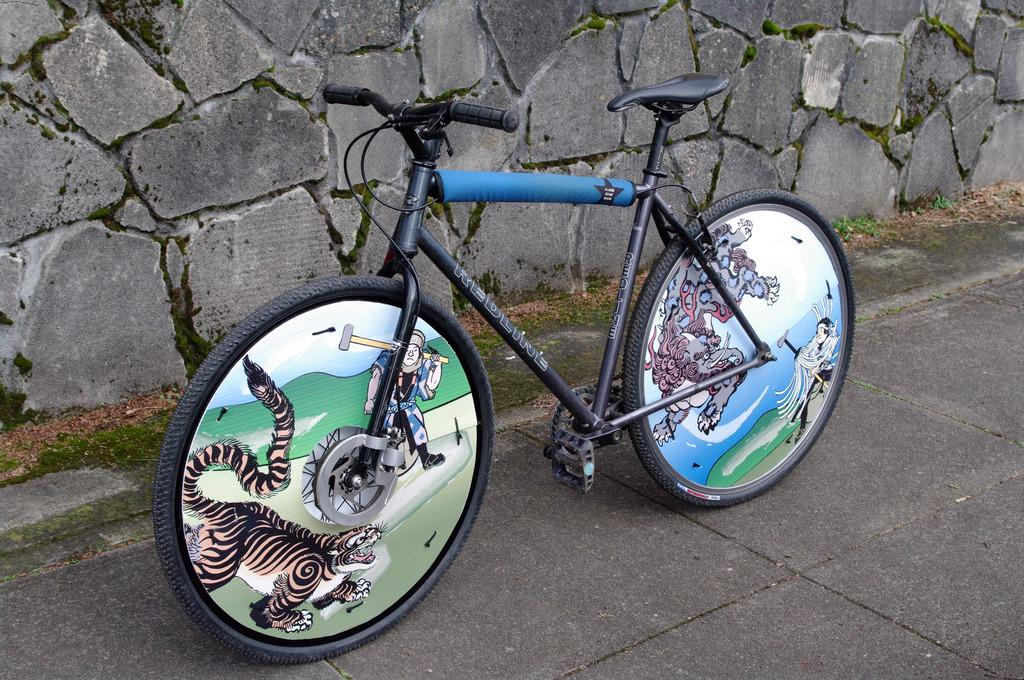What is the main object in the image? There is a bicycle in the image. Where is the bicycle located? The bicycle is on the road. What can be seen in the background of the image? There is a wall visible in the background of the image. What type of ornament is hanging from the wall in the image? There is no ornament hanging from the wall in the image; only the wall is visible in the background. 